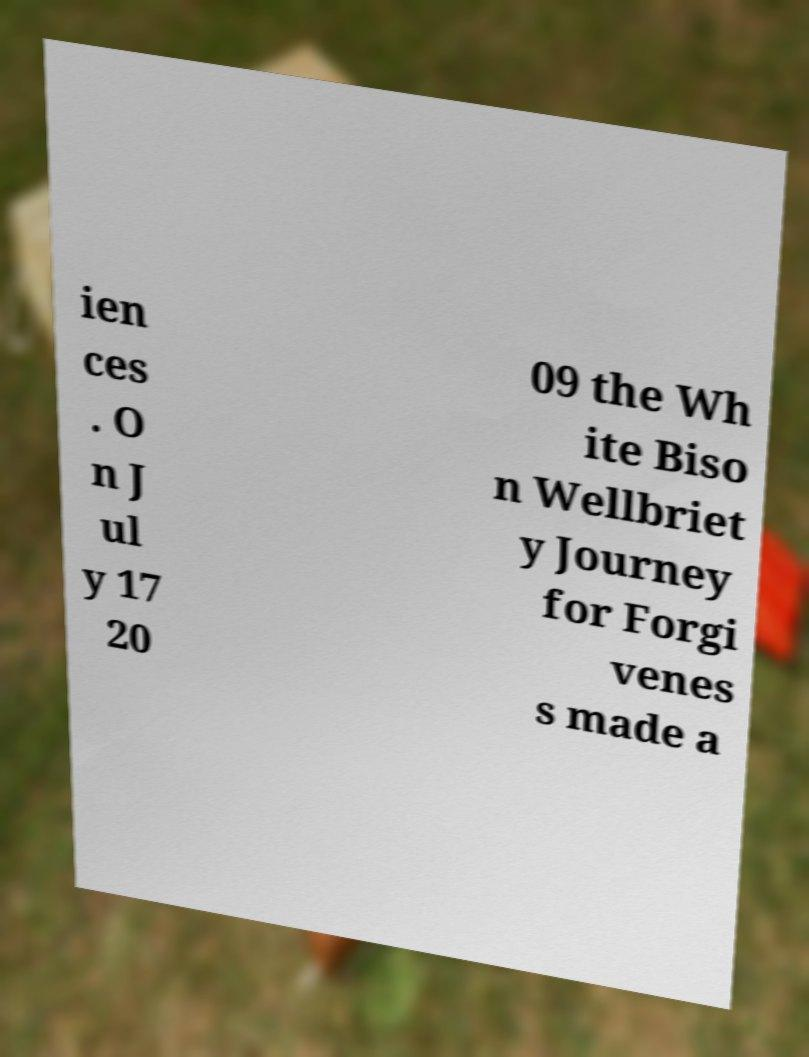I need the written content from this picture converted into text. Can you do that? ien ces . O n J ul y 17 20 09 the Wh ite Biso n Wellbriet y Journey for Forgi venes s made a 